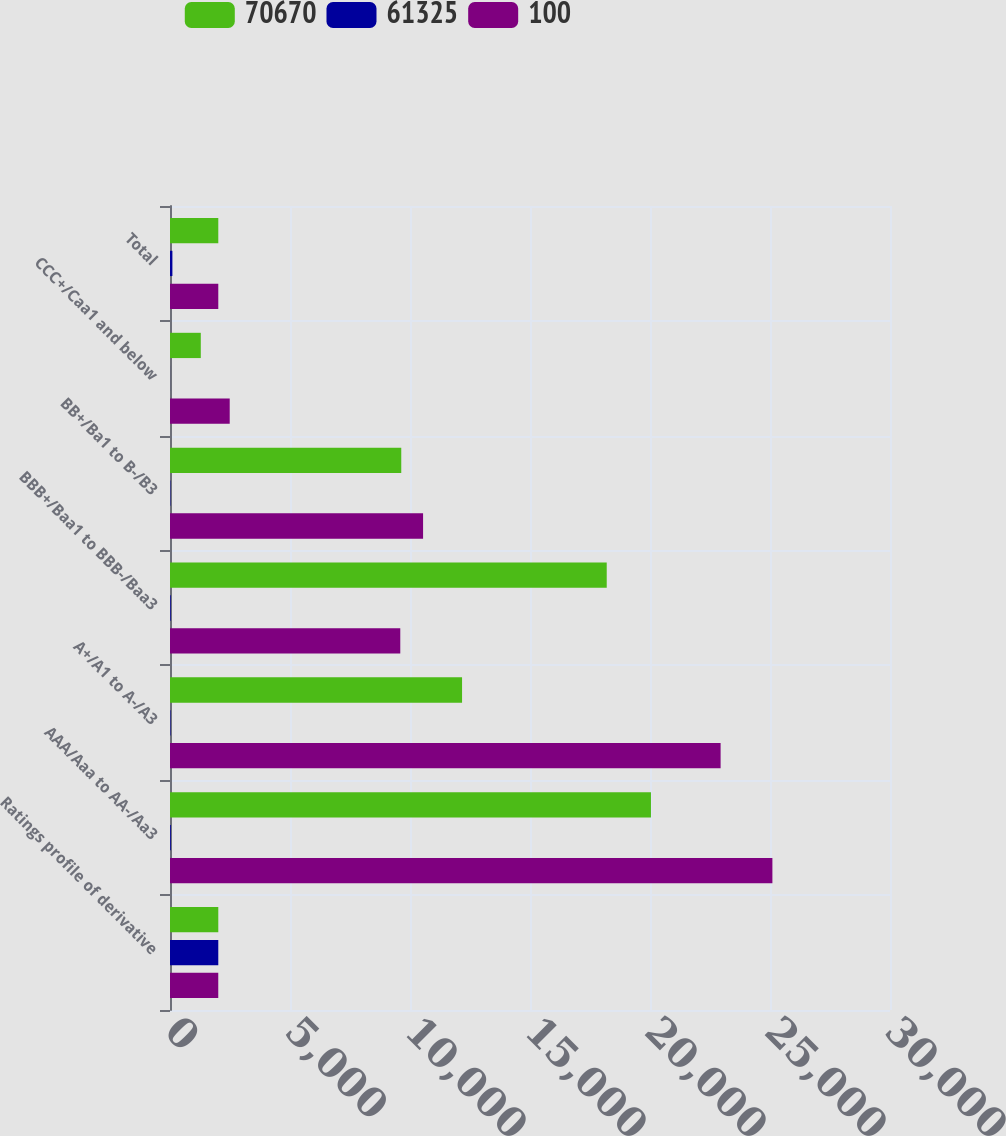Convert chart. <chart><loc_0><loc_0><loc_500><loc_500><stacked_bar_chart><ecel><fcel>Ratings profile of derivative<fcel>AAA/Aaa to AA-/Aa3<fcel>A+/A1 to A-/A3<fcel>BBB+/Baa1 to BBB-/Baa3<fcel>BB+/Ba1 to B-/B3<fcel>CCC+/Caa1 and below<fcel>Total<nl><fcel>70670<fcel>2012<fcel>20040<fcel>12169<fcel>18197<fcel>9636<fcel>1283<fcel>2012<nl><fcel>61325<fcel>2012<fcel>33<fcel>20<fcel>29<fcel>16<fcel>2<fcel>100<nl><fcel>100<fcel>2011<fcel>25100<fcel>22942<fcel>9595<fcel>10545<fcel>2488<fcel>2012<nl></chart> 